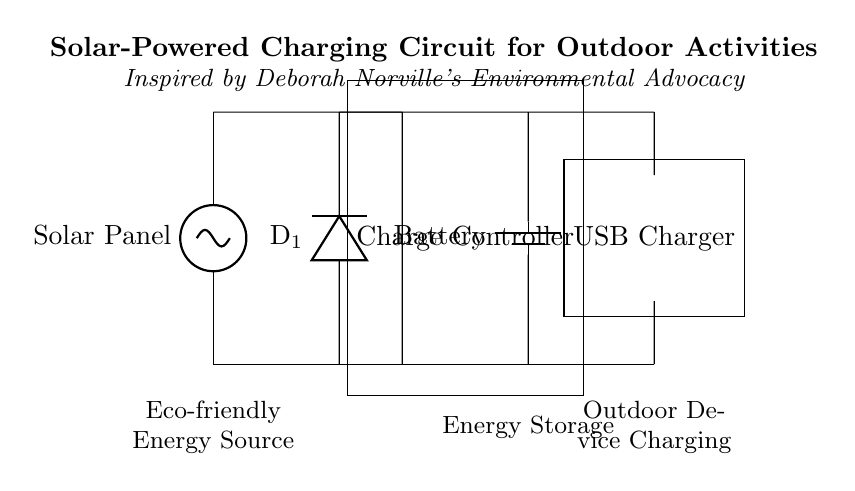What component provides power in this circuit? The solar panel is clearly labeled and is the source of energy for the circuit. It converts sunlight into electrical energy.
Answer: Solar Panel How many diodes are present in this circuit? The circuit diagram shows one diode, labeled as D1, allowing current to flow in one direction from the solar panel to the charge controller.
Answer: One What is the purpose of the charge controller? The charge controller is designed to regulate the voltage and current coming from the solar panel to ensure the battery is charged safely, preventing overcharging.
Answer: Regulate charging Which device is used for storing energy in this circuit? The battery is indicated as the energy storage component, depicted as a battery symbol, which stores energy generated by the solar panel.
Answer: Battery What function does the USB charger serve in this circuit? The USB charger is connected to the battery and is intended to convert the stored energy into a usable form for outdoor devices, typically providing USB output for charging.
Answer: Device charging Why does the circuit use a diode? A diode is used to prevent backflow of current from the battery to the solar panel, ensuring the correct flow of electricity, which is crucial for effective charging and protecting components.
Answer: Prevent backflow 